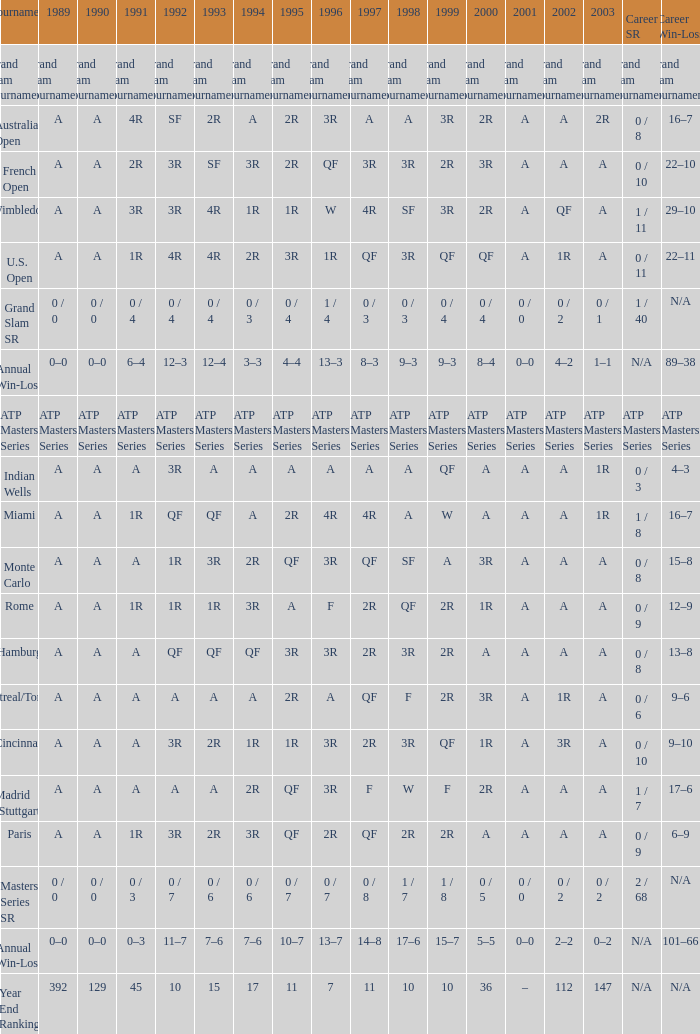In 1997, what is the value if the 1989 value is a, the 1995 value is qf, the 1996 value is 3r, and the career sr equals 0/8? QF. 